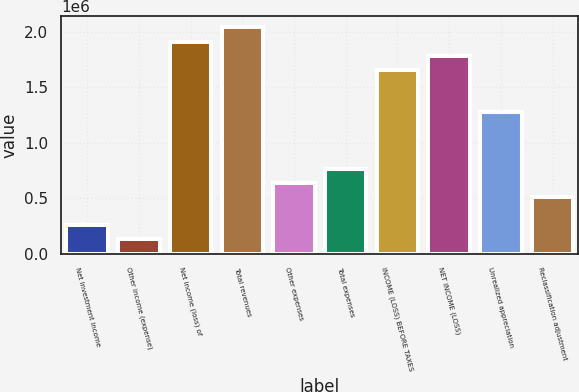Convert chart to OTSL. <chart><loc_0><loc_0><loc_500><loc_500><bar_chart><fcel>Net investment income<fcel>Other income (expense)<fcel>Net income (loss) of<fcel>Total revenues<fcel>Other expenses<fcel>Total expenses<fcel>INCOME (LOSS) BEFORE TAXES<fcel>NET INCOME (LOSS)<fcel>Unrealized appreciation<fcel>Reclassification adjustment<nl><fcel>255337<fcel>127749<fcel>1.91397e+06<fcel>2.04156e+06<fcel>638098<fcel>765686<fcel>1.6588e+06<fcel>1.78638e+06<fcel>1.27604e+06<fcel>510511<nl></chart> 